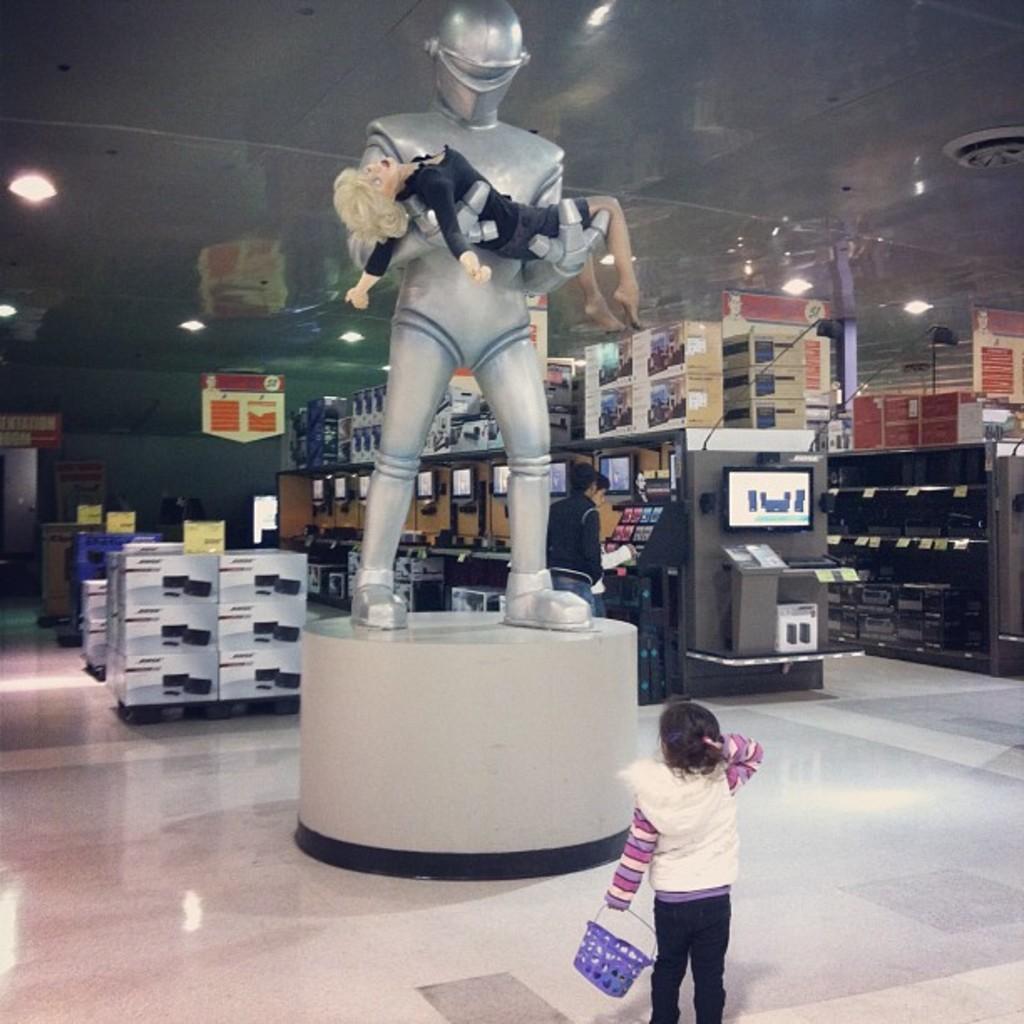Please provide a concise description of this image. In the center of the image there is a sculpture. At the bottom there is a pedestal. We can see a girl standing and holding a basket in her hand. In the background there are boxes, televisions and stands. At the top there are lights. 